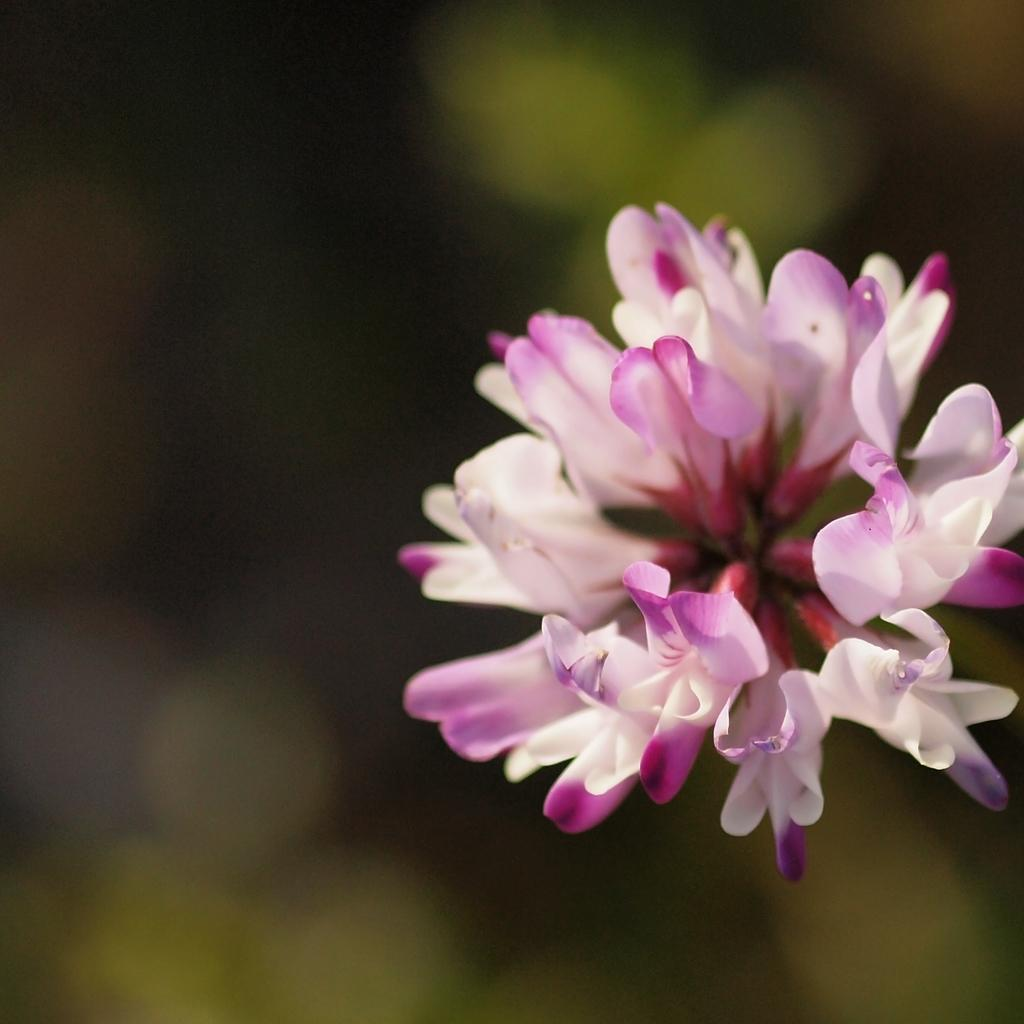What is the main subject of the image? There is a flower in the image. Can you describe anything in the background of the image? There is a green object in the background of the image. What is the lighting condition in the top left corner of the image? There is darkness in the top left corner of the image. What type of beef is being prepared for the voyage in the image? There is no beef or voyage present in the image; it features a flower and a green object in the background. 